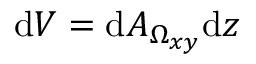Convert formula to latex. <formula><loc_0><loc_0><loc_500><loc_500>d V = d A _ { \Omega _ { x y } } d z</formula> 